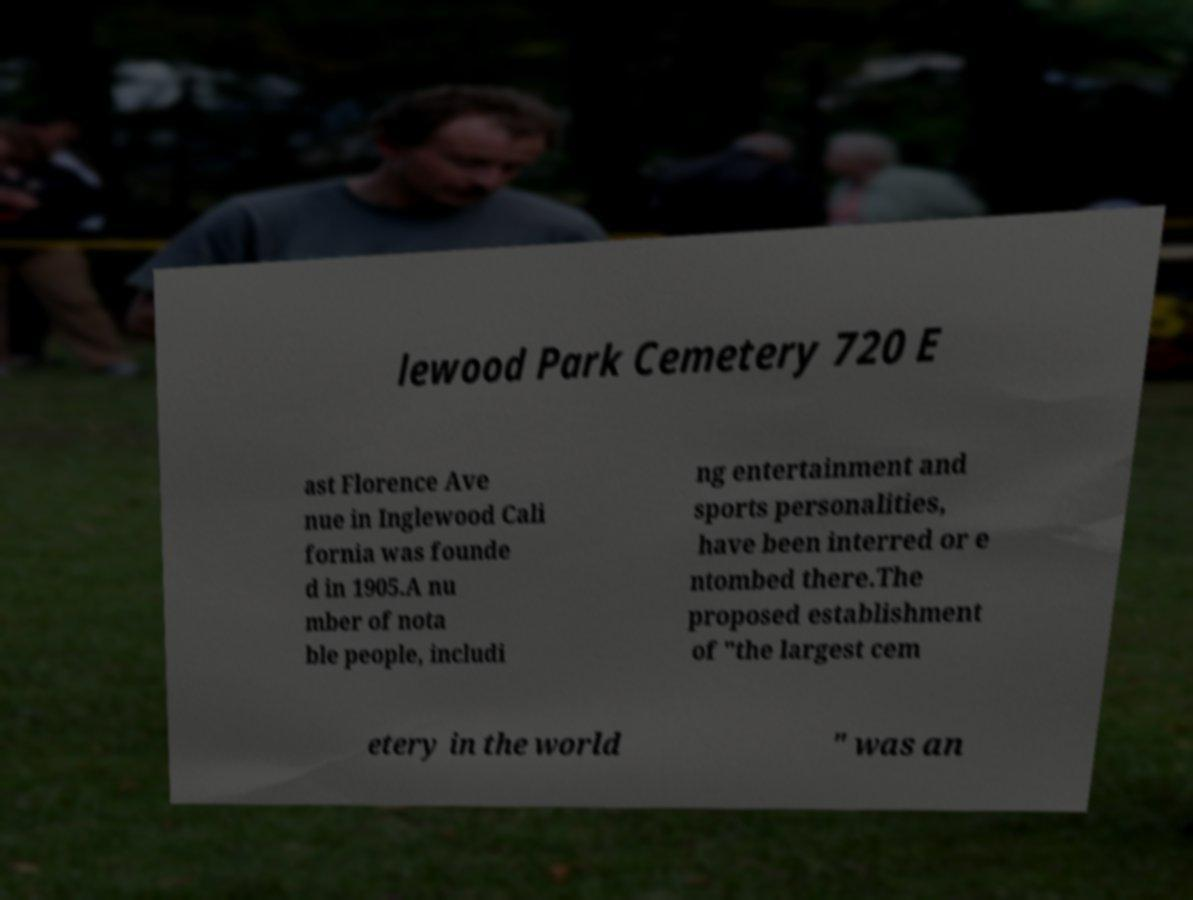There's text embedded in this image that I need extracted. Can you transcribe it verbatim? lewood Park Cemetery 720 E ast Florence Ave nue in Inglewood Cali fornia was founde d in 1905.A nu mber of nota ble people, includi ng entertainment and sports personalities, have been interred or e ntombed there.The proposed establishment of "the largest cem etery in the world " was an 